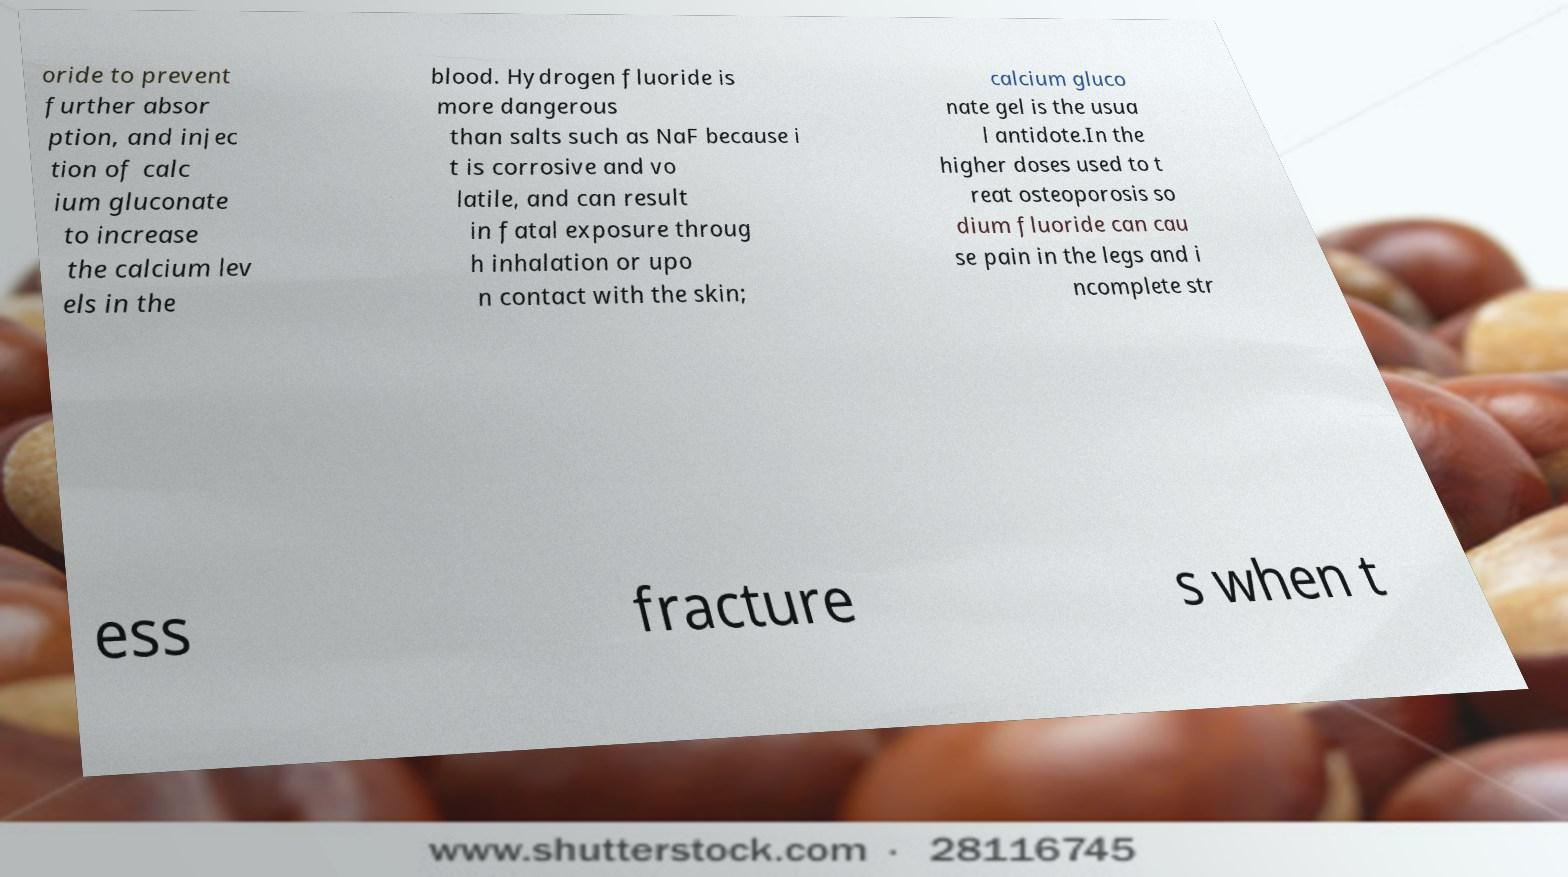Could you assist in decoding the text presented in this image and type it out clearly? oride to prevent further absor ption, and injec tion of calc ium gluconate to increase the calcium lev els in the blood. Hydrogen fluoride is more dangerous than salts such as NaF because i t is corrosive and vo latile, and can result in fatal exposure throug h inhalation or upo n contact with the skin; calcium gluco nate gel is the usua l antidote.In the higher doses used to t reat osteoporosis so dium fluoride can cau se pain in the legs and i ncomplete str ess fracture s when t 